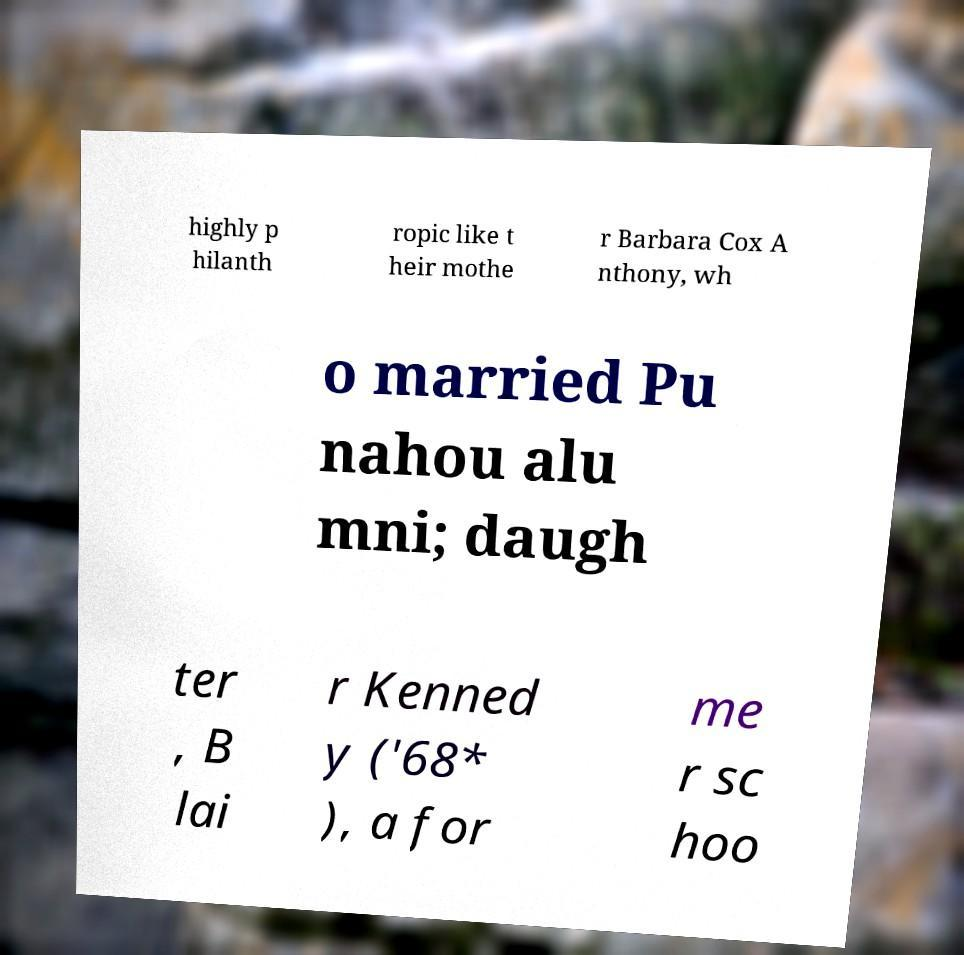I need the written content from this picture converted into text. Can you do that? highly p hilanth ropic like t heir mothe r Barbara Cox A nthony, wh o married Pu nahou alu mni; daugh ter , B lai r Kenned y ('68* ), a for me r sc hoo 